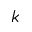<formula> <loc_0><loc_0><loc_500><loc_500>k</formula> 